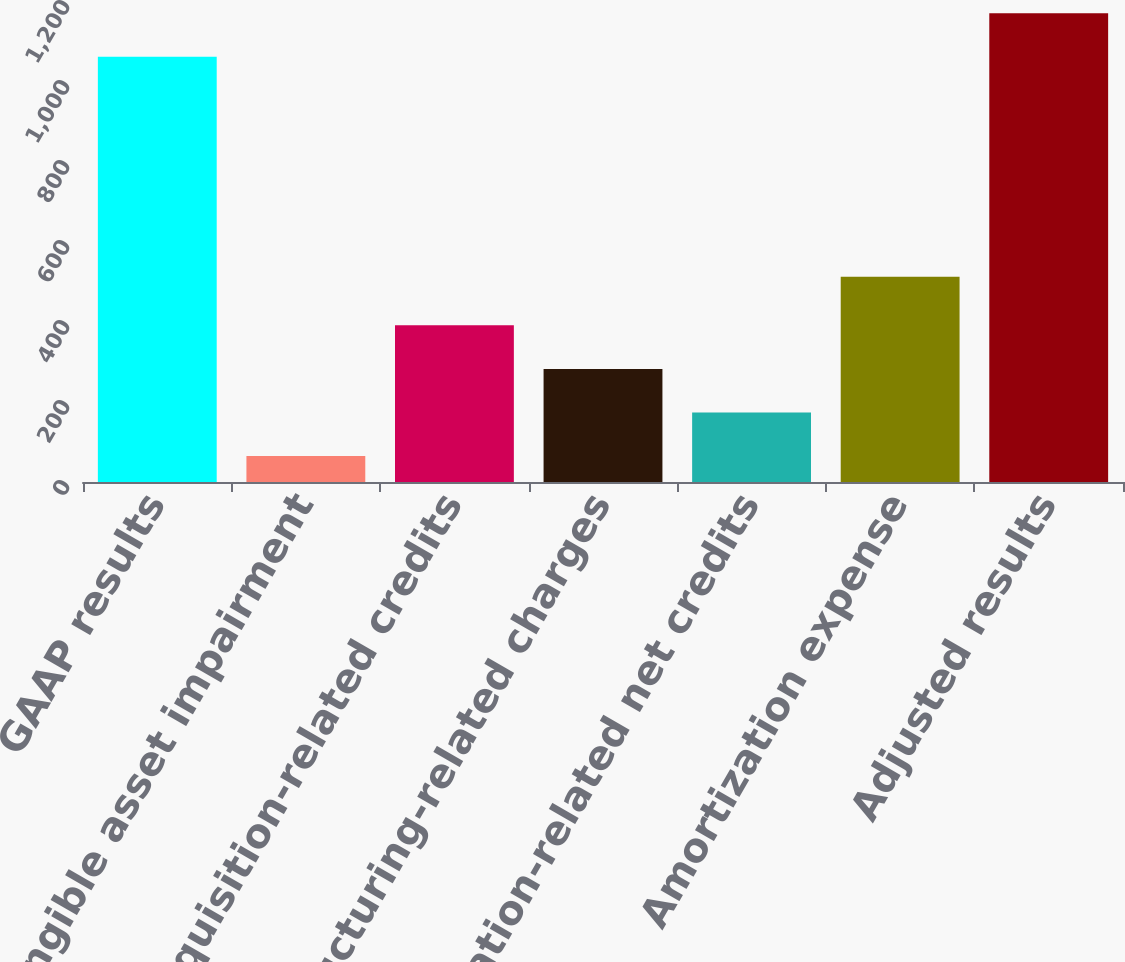Convert chart to OTSL. <chart><loc_0><loc_0><loc_500><loc_500><bar_chart><fcel>GAAP results<fcel>Intangible asset impairment<fcel>Acquisition-related credits<fcel>Restructuring-related charges<fcel>Litigation-related net credits<fcel>Amortization expense<fcel>Adjusted results<nl><fcel>1063<fcel>65<fcel>391.7<fcel>282.8<fcel>173.9<fcel>513<fcel>1171.9<nl></chart> 